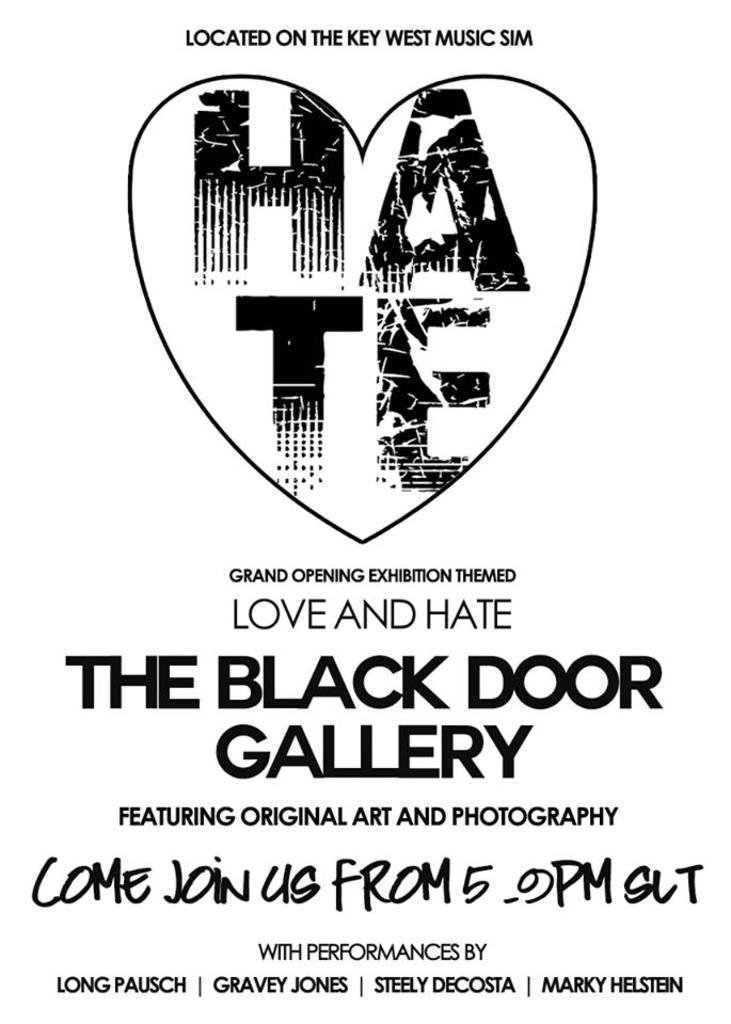<image>
Give a short and clear explanation of the subsequent image. A white background poster for the exhibition The Black Door Gallery. 